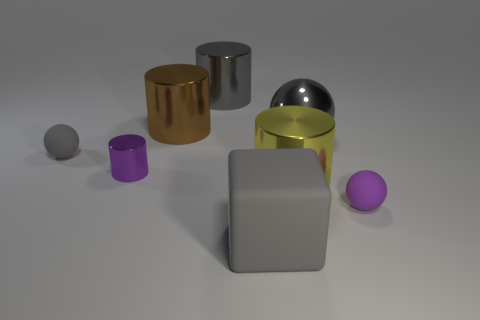Subtract all large yellow cylinders. How many cylinders are left? 3 Subtract all yellow cubes. How many gray spheres are left? 2 Subtract all gray cylinders. How many cylinders are left? 3 Add 1 purple rubber things. How many objects exist? 9 Subtract all blocks. How many objects are left? 7 Subtract all purple cylinders. Subtract all cyan balls. How many cylinders are left? 3 Add 5 large balls. How many large balls exist? 6 Subtract 1 gray cubes. How many objects are left? 7 Subtract all cyan balls. Subtract all yellow things. How many objects are left? 7 Add 2 big things. How many big things are left? 7 